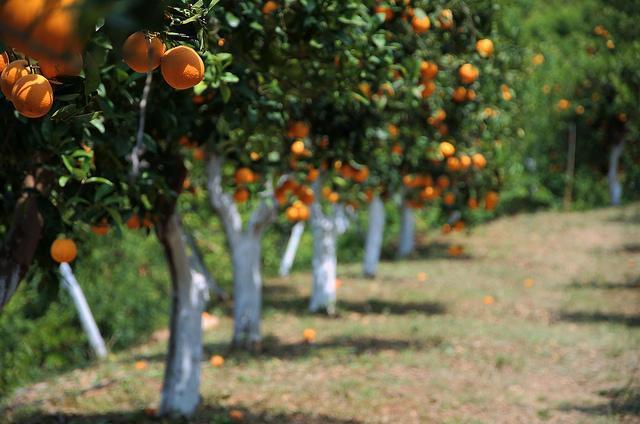How many oranges are visible?
Give a very brief answer. 2. 